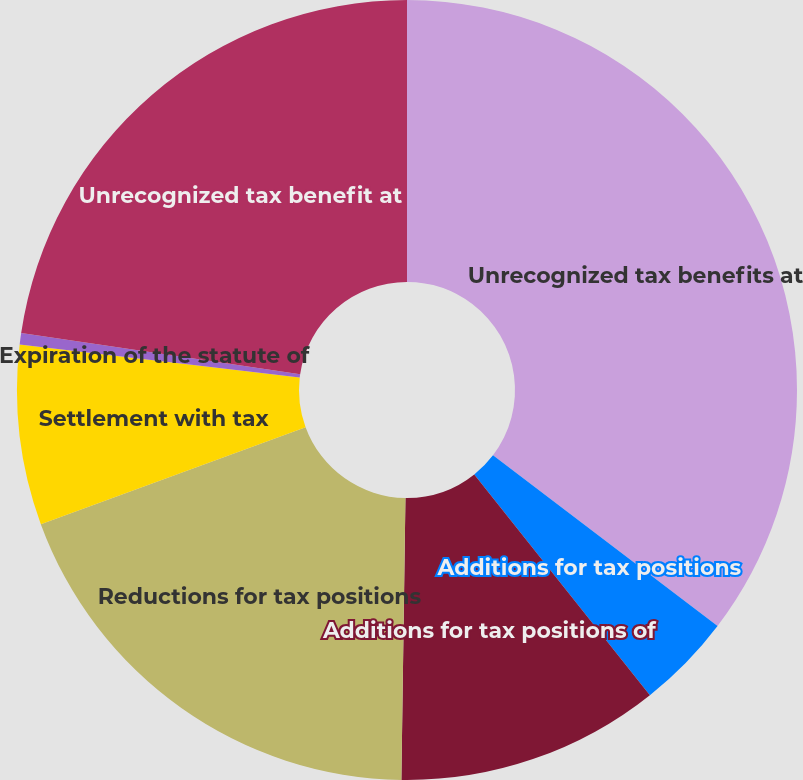<chart> <loc_0><loc_0><loc_500><loc_500><pie_chart><fcel>Unrecognized tax benefits at<fcel>Additions for tax positions<fcel>Additions for tax positions of<fcel>Reductions for tax positions<fcel>Settlement with tax<fcel>Expiration of the statute of<fcel>Unrecognized tax benefit at<nl><fcel>35.34%<fcel>3.96%<fcel>10.93%<fcel>19.18%<fcel>7.45%<fcel>0.47%<fcel>22.67%<nl></chart> 